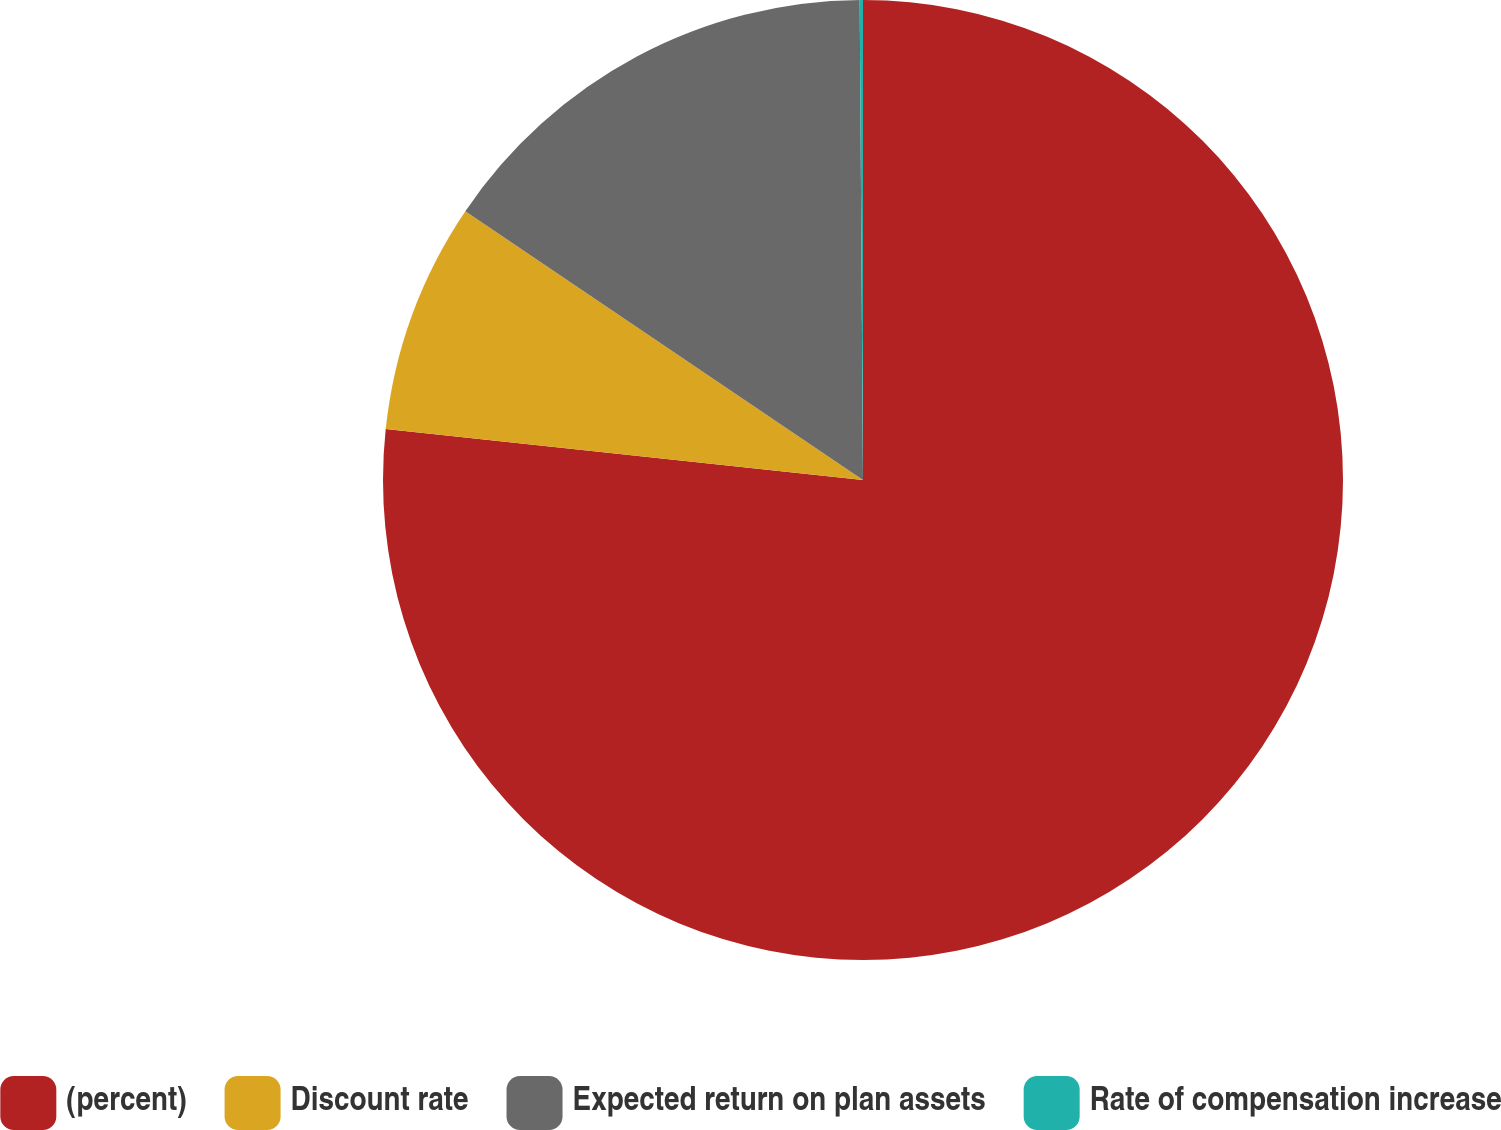Convert chart. <chart><loc_0><loc_0><loc_500><loc_500><pie_chart><fcel>(percent)<fcel>Discount rate<fcel>Expected return on plan assets<fcel>Rate of compensation increase<nl><fcel>76.7%<fcel>7.77%<fcel>15.43%<fcel>0.11%<nl></chart> 